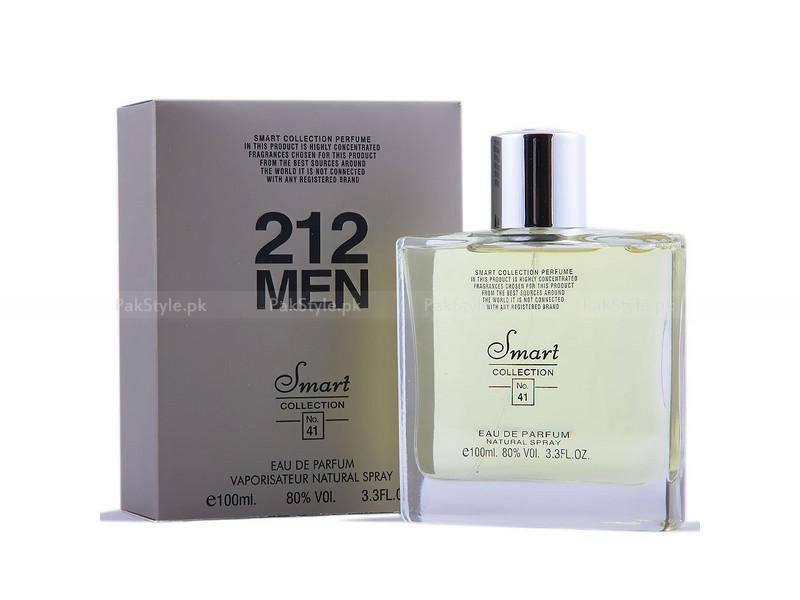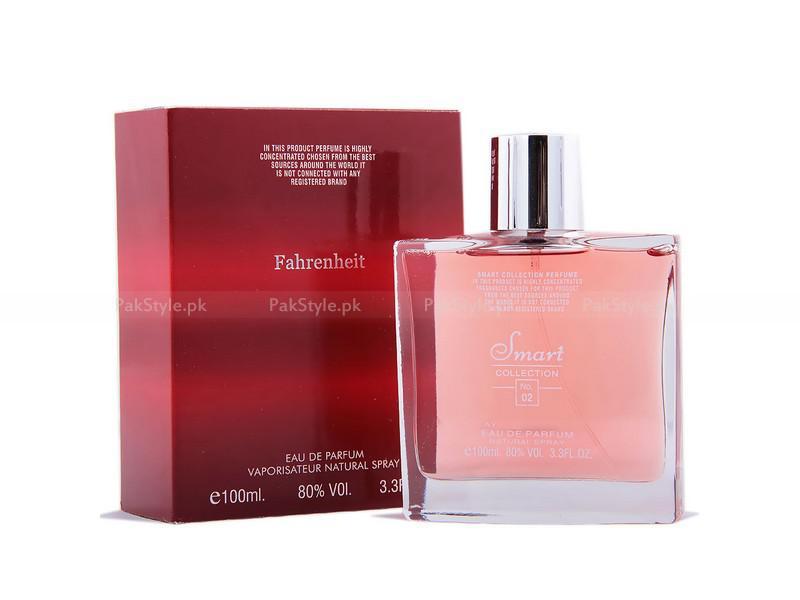The first image is the image on the left, the second image is the image on the right. Considering the images on both sides, is "A square bottle of pale yellowish liquid stands to the right and slightly overlapping its box." valid? Answer yes or no. Yes. The first image is the image on the left, the second image is the image on the right. For the images shown, is this caption "There are more bottles of perfume with rounded edges than there are with sharp edges." true? Answer yes or no. No. 